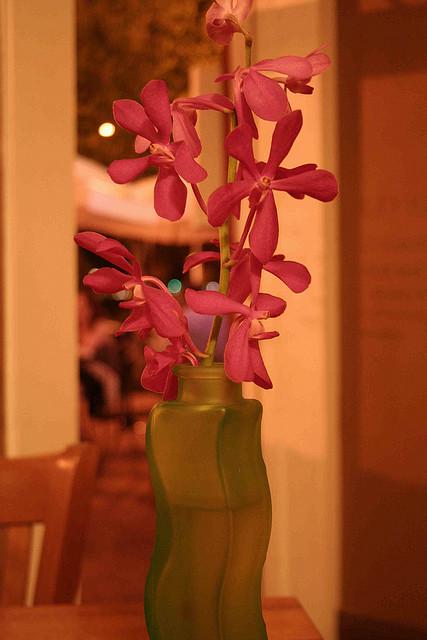What color are the flowers?
Concise answer only. Pink. Are these flowers real?
Keep it brief. Yes. What color is the vase?
Quick response, please. Green. 